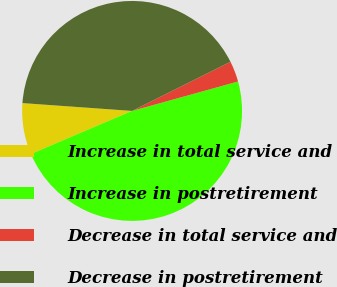<chart> <loc_0><loc_0><loc_500><loc_500><pie_chart><fcel>Increase in total service and<fcel>Increase in postretirement<fcel>Decrease in total service and<fcel>Decrease in postretirement<nl><fcel>7.55%<fcel>47.9%<fcel>3.06%<fcel>41.49%<nl></chart> 